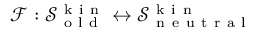<formula> <loc_0><loc_0><loc_500><loc_500>\mathcal { F } \colon \mathcal { S } _ { o l d } ^ { k i n } \leftrightarrow \mathcal { S } _ { n e u t r a l } ^ { k i n }</formula> 